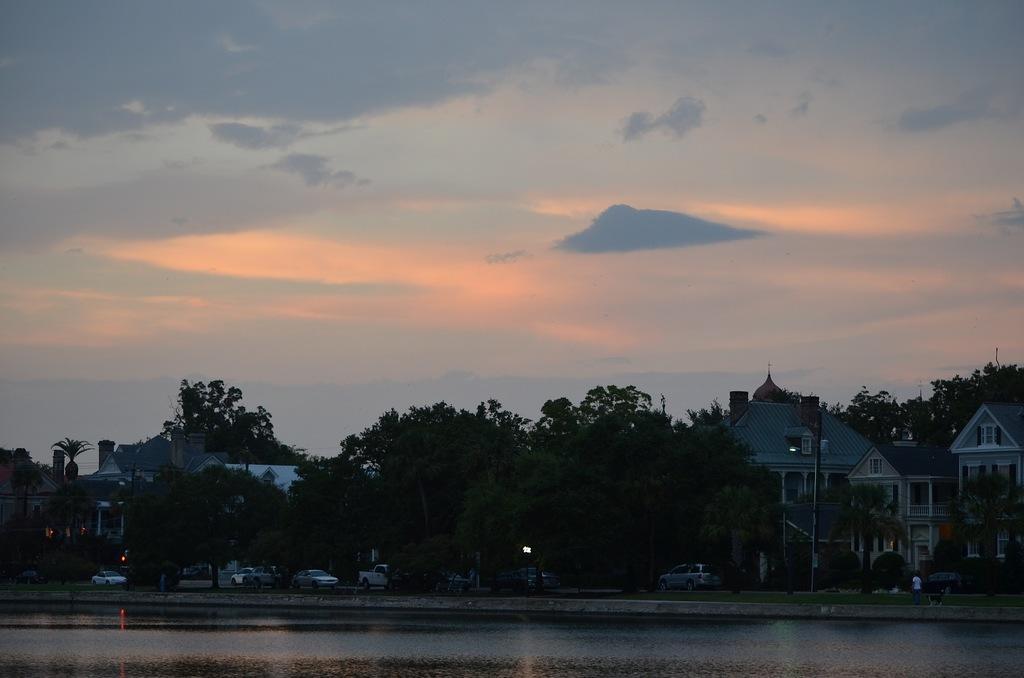Describe this image in one or two sentences. In this image in the center there is an object which is shining. In the background there are cars, there is grass on the ground, there are trees, buildings and the sky is cloudy. 